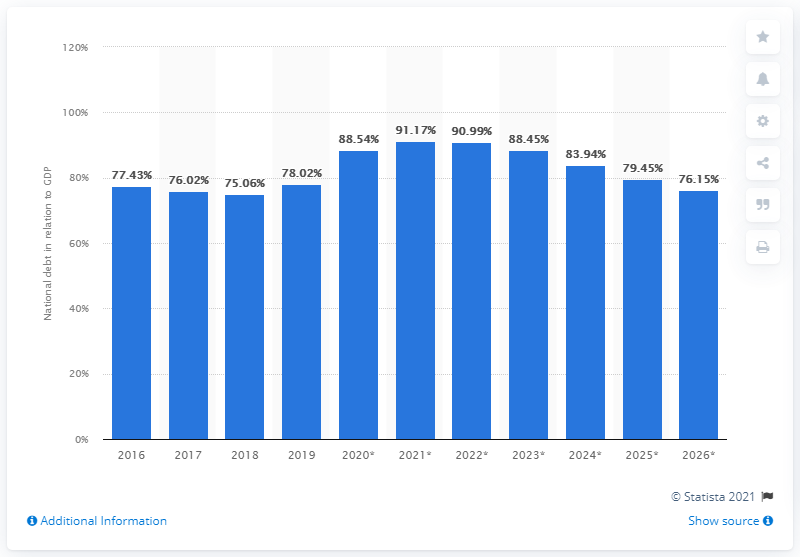Point out several critical features in this image. In 2019, the national debt of Jordan was approximately 78.02. 